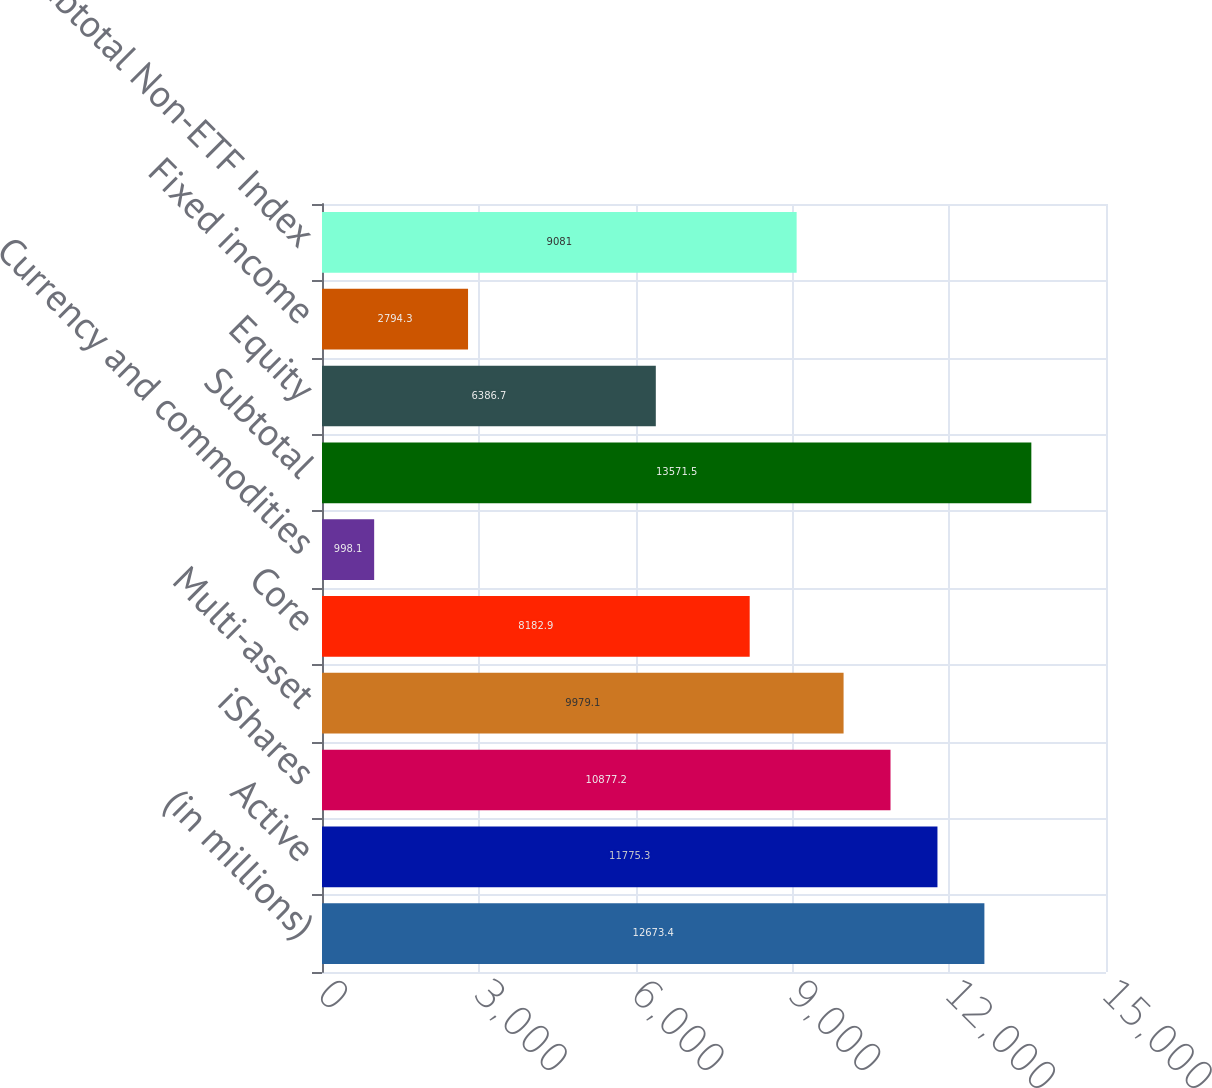<chart> <loc_0><loc_0><loc_500><loc_500><bar_chart><fcel>(in millions)<fcel>Active<fcel>iShares<fcel>Multi-asset<fcel>Core<fcel>Currency and commodities<fcel>Subtotal<fcel>Equity<fcel>Fixed income<fcel>Subtotal Non-ETF Index<nl><fcel>12673.4<fcel>11775.3<fcel>10877.2<fcel>9979.1<fcel>8182.9<fcel>998.1<fcel>13571.5<fcel>6386.7<fcel>2794.3<fcel>9081<nl></chart> 